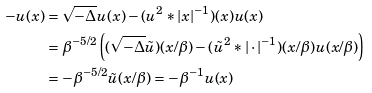Convert formula to latex. <formula><loc_0><loc_0><loc_500><loc_500>- u ( x ) & = \sqrt { - \Delta } u ( x ) - ( u ^ { 2 } * | x | ^ { - 1 } ) ( x ) u ( x ) \\ & = \beta ^ { - 5 / 2 } \left ( ( \sqrt { - \Delta } \tilde { u } ) ( x / \beta ) - ( \tilde { u } ^ { 2 } * | \cdot | ^ { - 1 } ) ( x / \beta ) u ( x / \beta ) \right ) \\ & = - \beta ^ { - 5 / 2 } \tilde { u } ( x / \beta ) = - \beta ^ { - 1 } u ( x )</formula> 